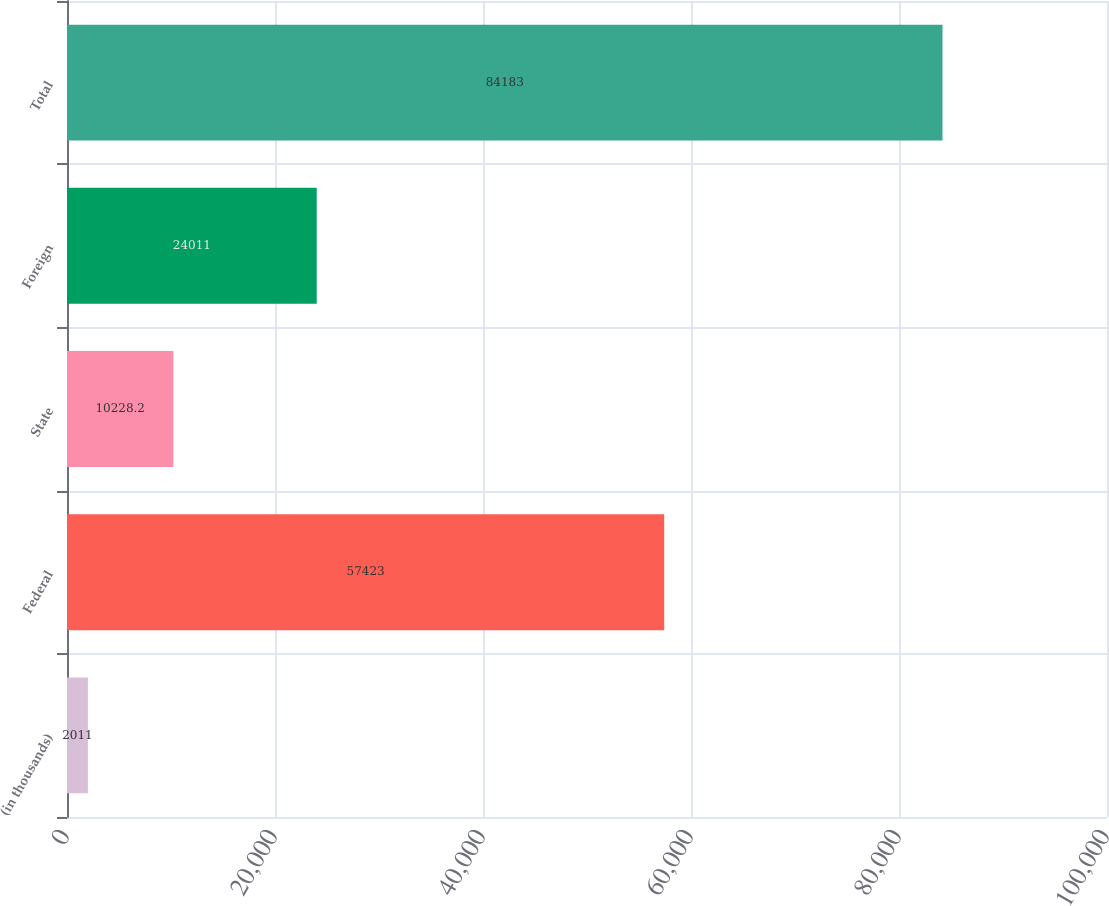Convert chart to OTSL. <chart><loc_0><loc_0><loc_500><loc_500><bar_chart><fcel>(in thousands)<fcel>Federal<fcel>State<fcel>Foreign<fcel>Total<nl><fcel>2011<fcel>57423<fcel>10228.2<fcel>24011<fcel>84183<nl></chart> 